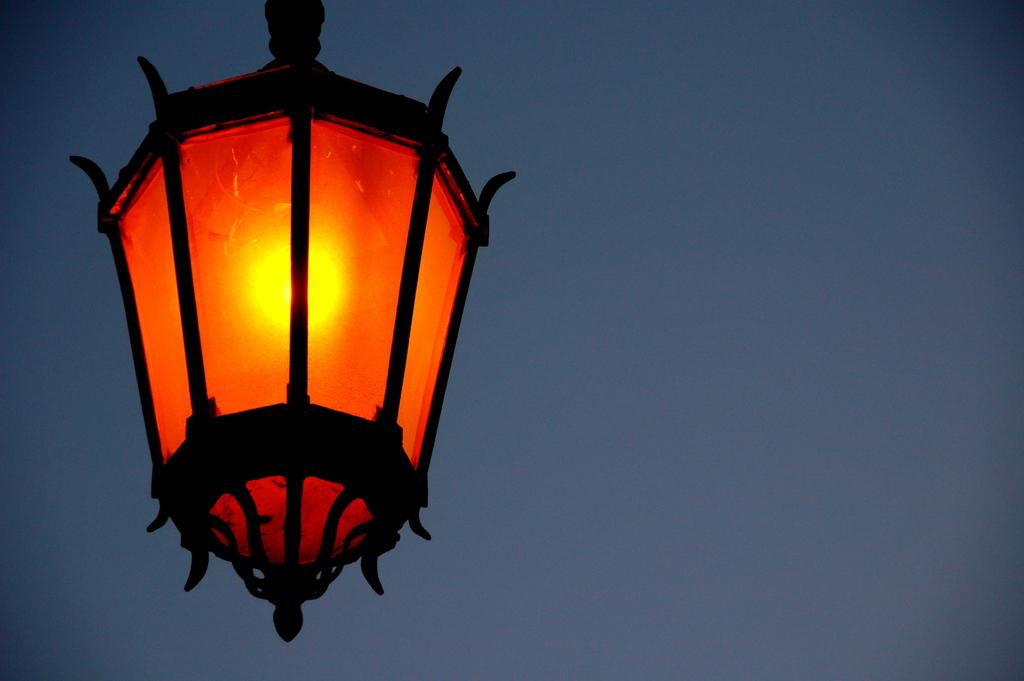What object can be seen in the image that provides light? There is a lamp in the image. What is the main component of the lamp that produces light? The lamp contains a bulb. What is the color of the light produced by the bulb? The bulb is yellow in color. Where is the lead used in the image? There is no lead present in the image. Can you see a nest in the image? There is no nest present in the image. Are there any beads visible in the image? There are no beads present in the image. 